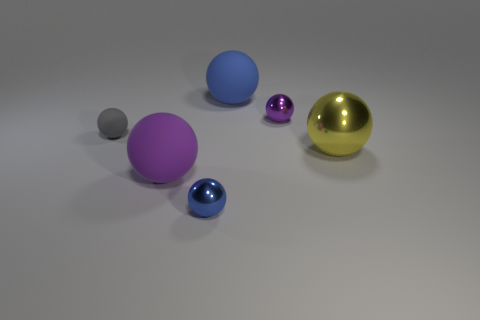Subtract 2 spheres. How many spheres are left? 4 Subtract all blue balls. How many balls are left? 4 Subtract all tiny purple metal spheres. How many spheres are left? 5 Subtract all cyan spheres. Subtract all green cubes. How many spheres are left? 6 Add 2 tiny matte spheres. How many objects exist? 8 Subtract all gray matte things. Subtract all tiny metallic things. How many objects are left? 3 Add 5 purple spheres. How many purple spheres are left? 7 Add 3 blue metallic objects. How many blue metallic objects exist? 4 Subtract 0 blue blocks. How many objects are left? 6 